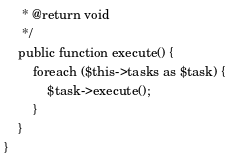Convert code to text. <code><loc_0><loc_0><loc_500><loc_500><_PHP_>     * @return void
     */
    public function execute() {
        foreach ($this->tasks as $task) {
            $task->execute();
        }
    }
}
</code> 